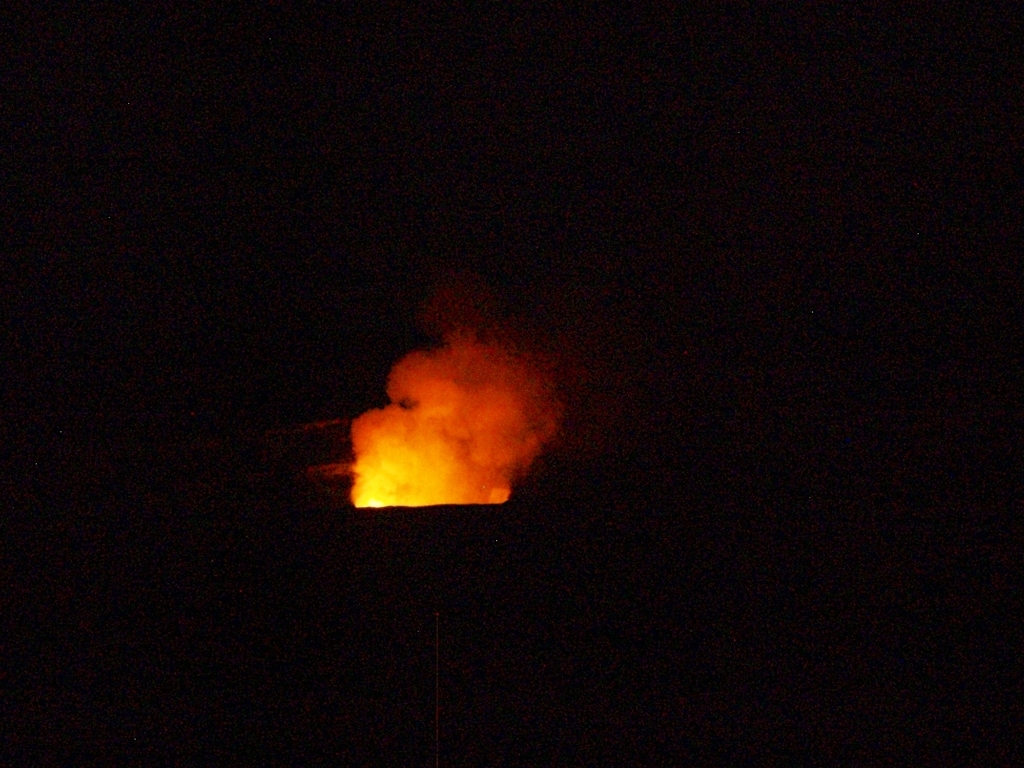Are there any specific photography techniques that could enhance images like this? For dynamic events like a fire at night, photographers may use long exposure techniques to capture the trails of light and movement of the flames. A tripod is essential to prevent camera shake during the extended exposure. A lower ISO can reduce grain, and adjusting the white balance can ensure the fire's color is accurately represented. Night photography often benefits from shooting in RAW format for greater post-processing flexibility. 